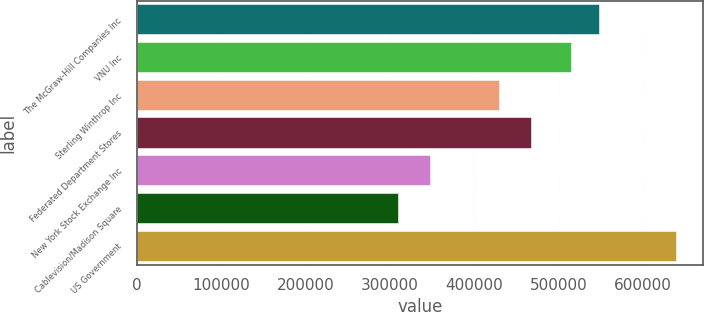<chart> <loc_0><loc_0><loc_500><loc_500><bar_chart><fcel>The McGraw-Hill Companies Inc<fcel>VNU Inc<fcel>Sterling Winthrop Inc<fcel>Federated Department Stores<fcel>New York Stock Exchange Inc<fcel>Cablevision/Madison Square<fcel>US Government<nl><fcel>547900<fcel>515000<fcel>429000<fcel>467000<fcel>348000<fcel>310000<fcel>639000<nl></chart> 